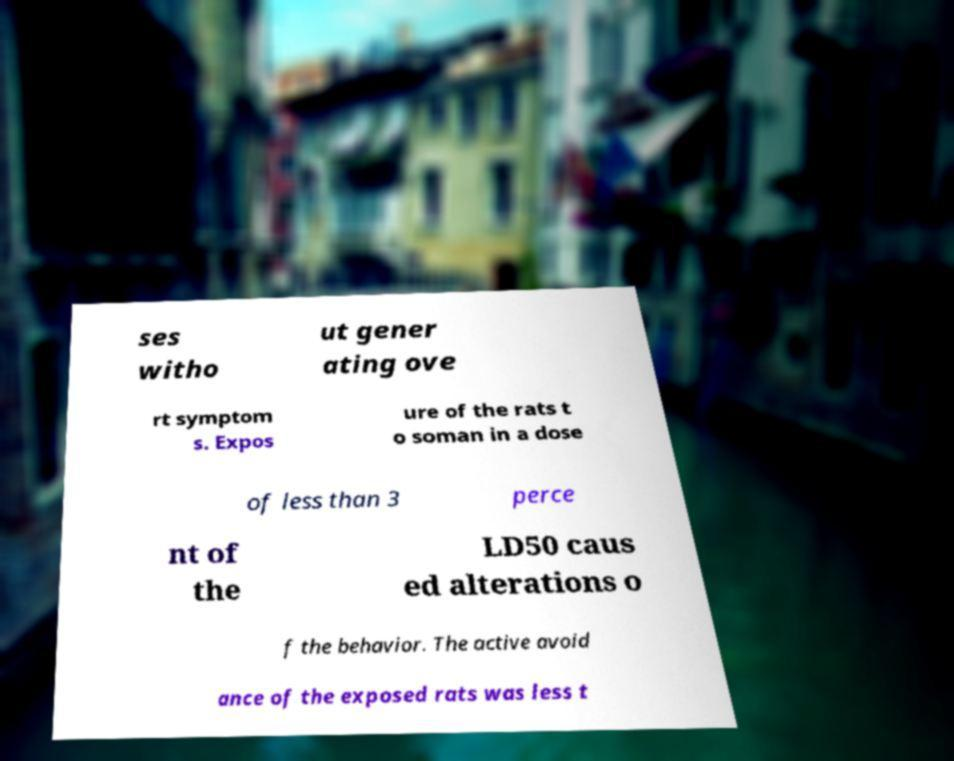Please identify and transcribe the text found in this image. ses witho ut gener ating ove rt symptom s. Expos ure of the rats t o soman in a dose of less than 3 perce nt of the LD50 caus ed alterations o f the behavior. The active avoid ance of the exposed rats was less t 